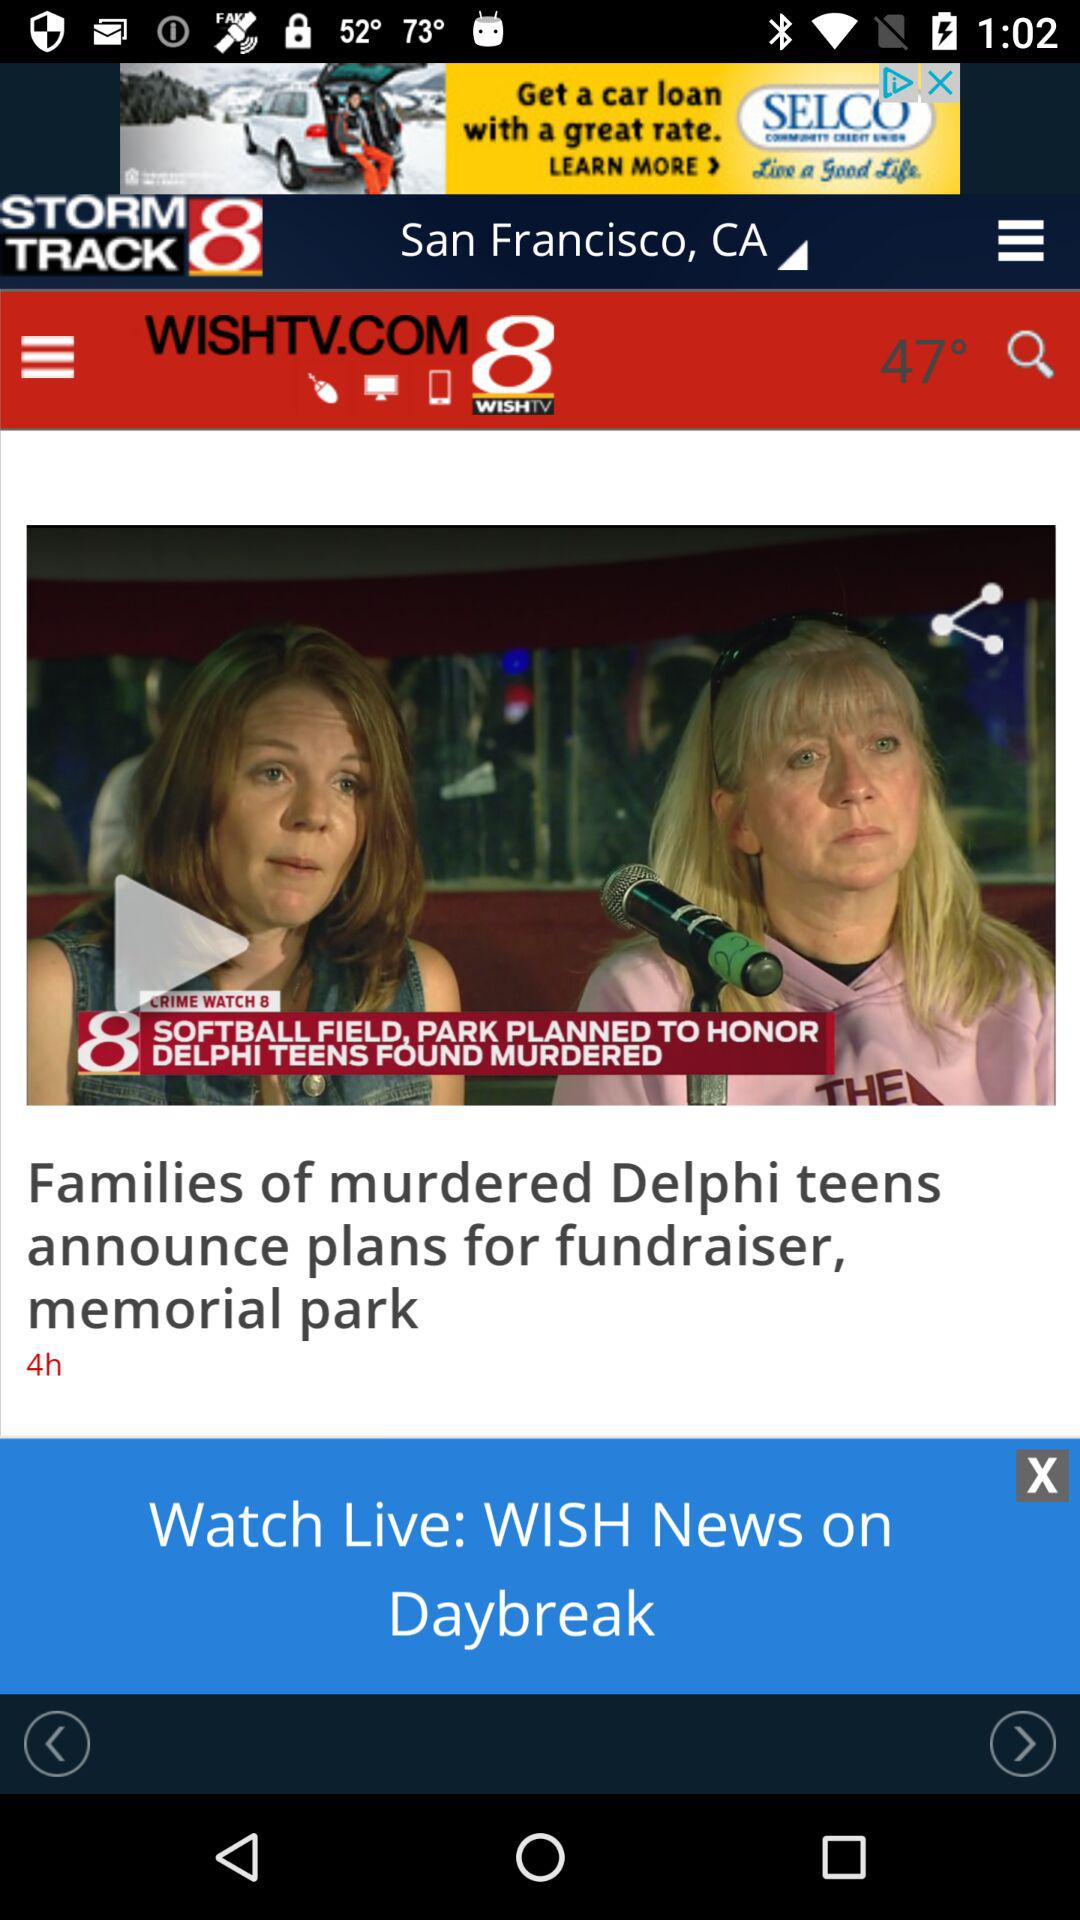How many hours ago was the "Families of murdered Delphi teens" news posted? The news was posted 4 hours ago. 